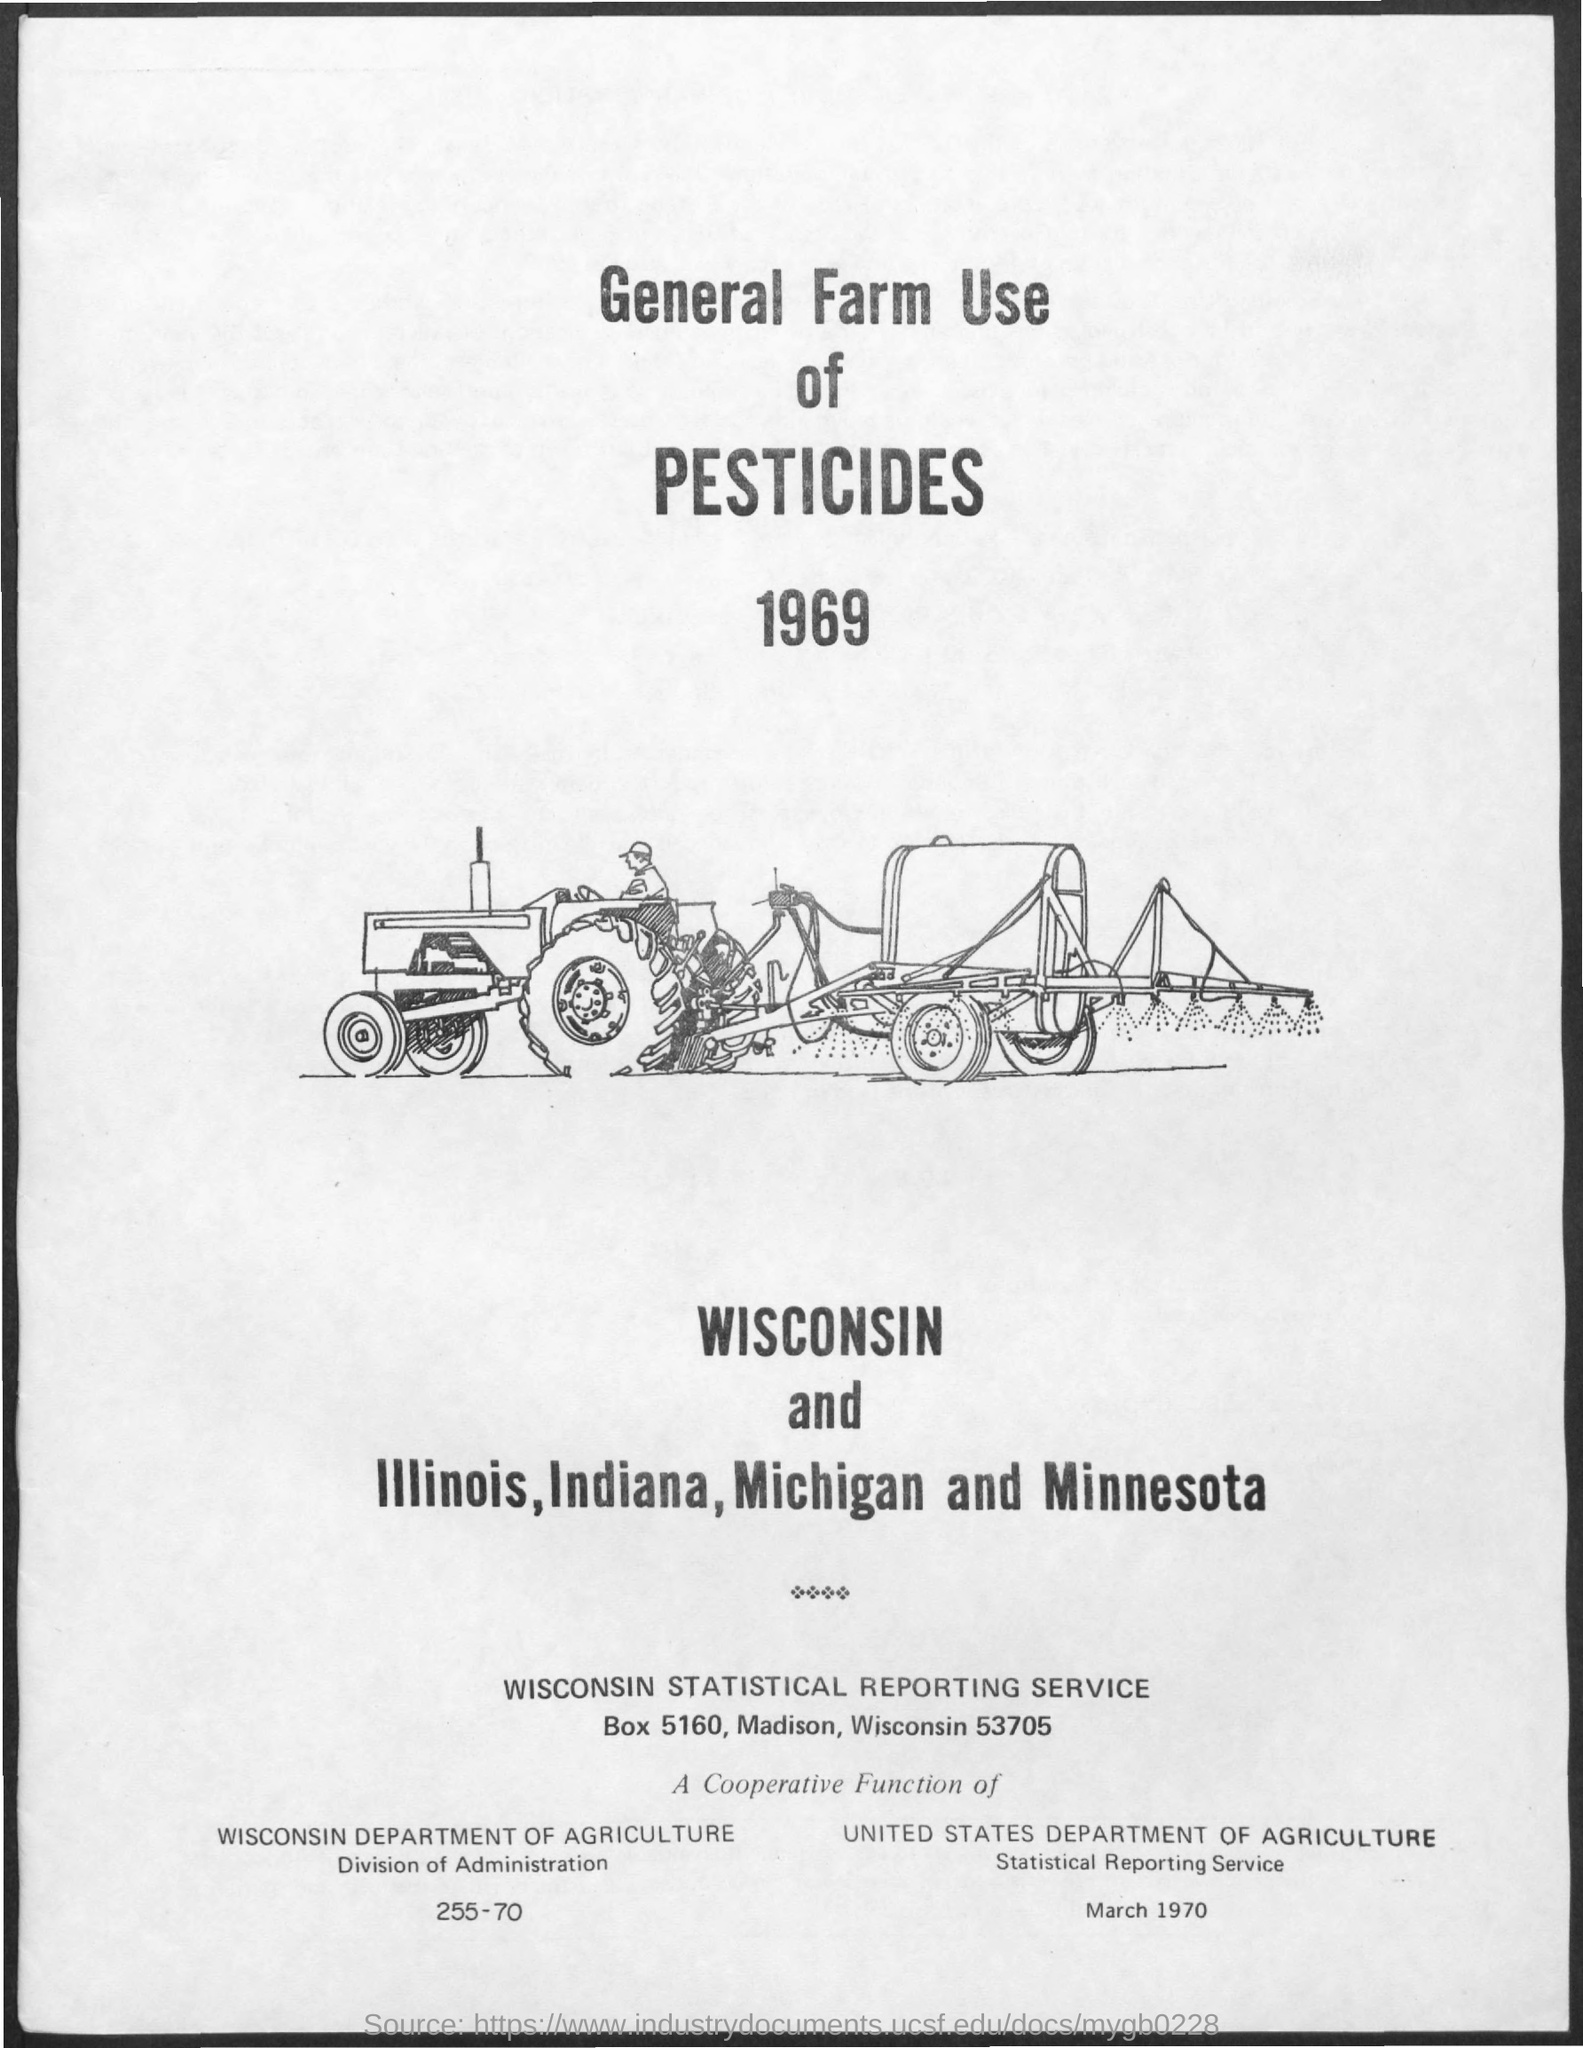What is the address for Wisconsin statistical reporting service?
Keep it short and to the point. Box 5160, madison, wisconsin 53705. What is the Title of the document?
Keep it short and to the point. General farm use of pesticides. 